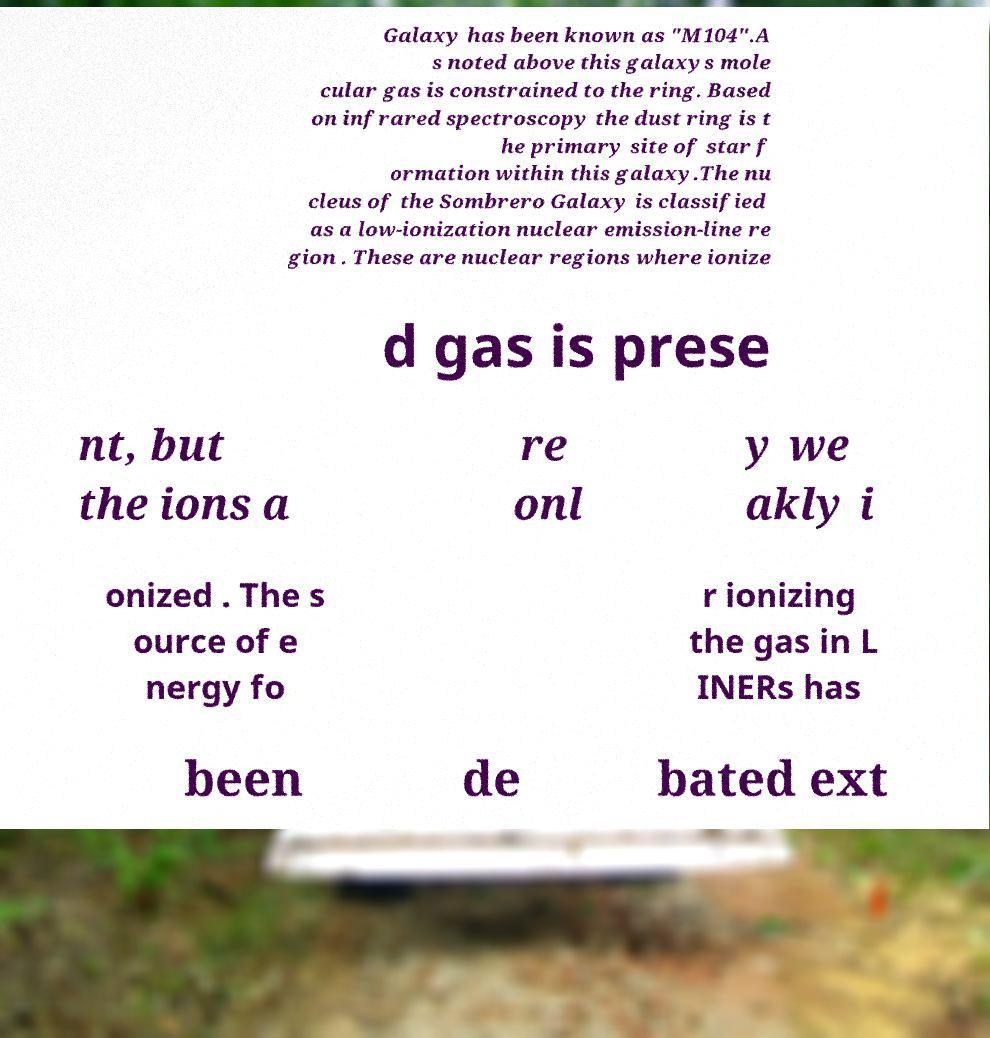Please read and relay the text visible in this image. What does it say? Galaxy has been known as "M104".A s noted above this galaxys mole cular gas is constrained to the ring. Based on infrared spectroscopy the dust ring is t he primary site of star f ormation within this galaxy.The nu cleus of the Sombrero Galaxy is classified as a low-ionization nuclear emission-line re gion . These are nuclear regions where ionize d gas is prese nt, but the ions a re onl y we akly i onized . The s ource of e nergy fo r ionizing the gas in L INERs has been de bated ext 